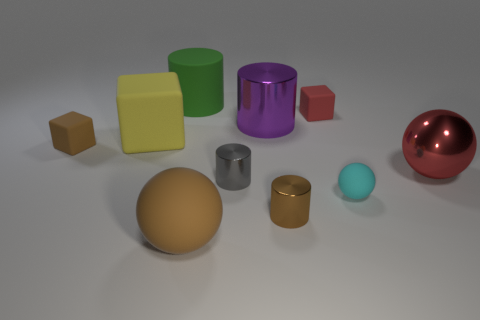Subtract all red matte blocks. How many blocks are left? 2 Subtract all brown blocks. How many blocks are left? 2 Subtract all blue matte cubes. Subtract all big matte balls. How many objects are left? 9 Add 4 large red metal balls. How many large red metal balls are left? 5 Add 5 brown matte objects. How many brown matte objects exist? 7 Subtract 0 blue blocks. How many objects are left? 10 Subtract all cubes. How many objects are left? 7 Subtract 4 cylinders. How many cylinders are left? 0 Subtract all yellow blocks. Subtract all cyan balls. How many blocks are left? 2 Subtract all brown cylinders. How many cyan blocks are left? 0 